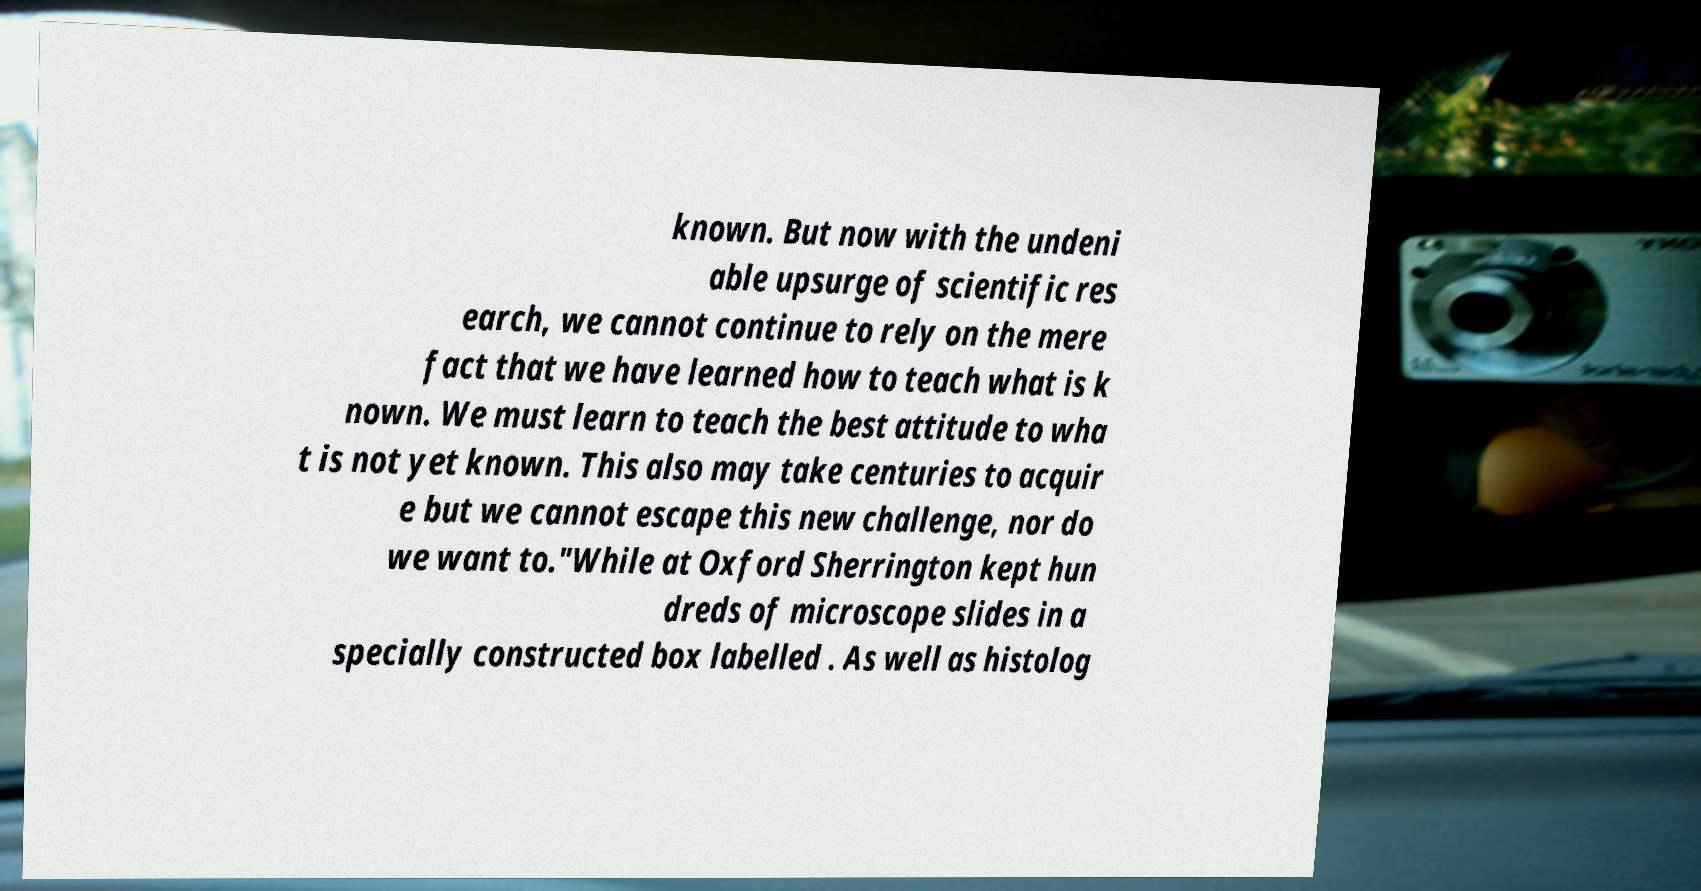Can you read and provide the text displayed in the image?This photo seems to have some interesting text. Can you extract and type it out for me? known. But now with the undeni able upsurge of scientific res earch, we cannot continue to rely on the mere fact that we have learned how to teach what is k nown. We must learn to teach the best attitude to wha t is not yet known. This also may take centuries to acquir e but we cannot escape this new challenge, nor do we want to."While at Oxford Sherrington kept hun dreds of microscope slides in a specially constructed box labelled . As well as histolog 